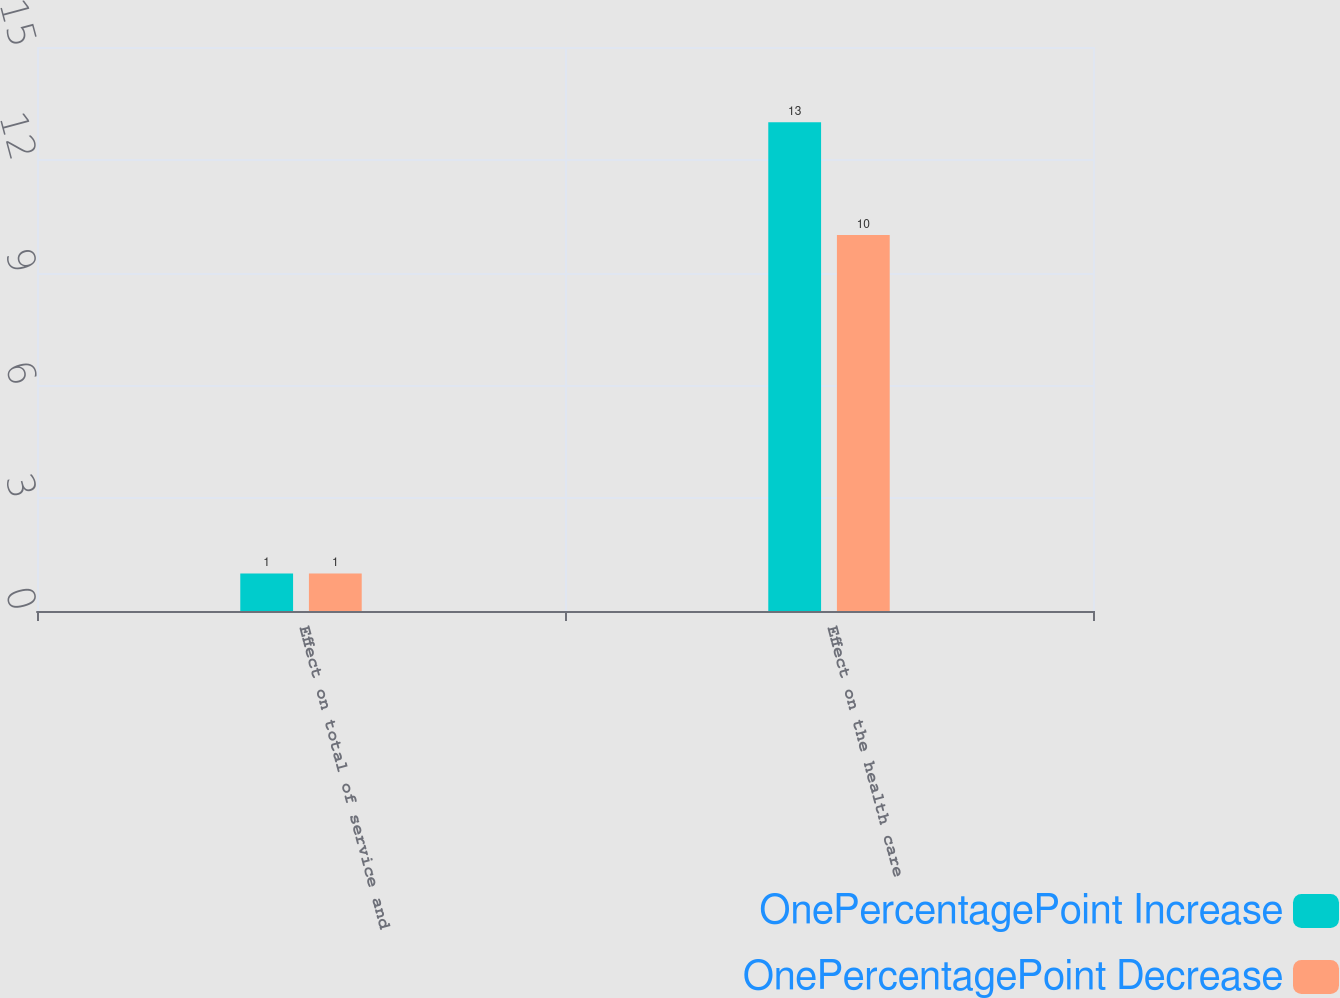Convert chart. <chart><loc_0><loc_0><loc_500><loc_500><stacked_bar_chart><ecel><fcel>Effect on total of service and<fcel>Effect on the health care<nl><fcel>OnePercentagePoint Increase<fcel>1<fcel>13<nl><fcel>OnePercentagePoint Decrease<fcel>1<fcel>10<nl></chart> 